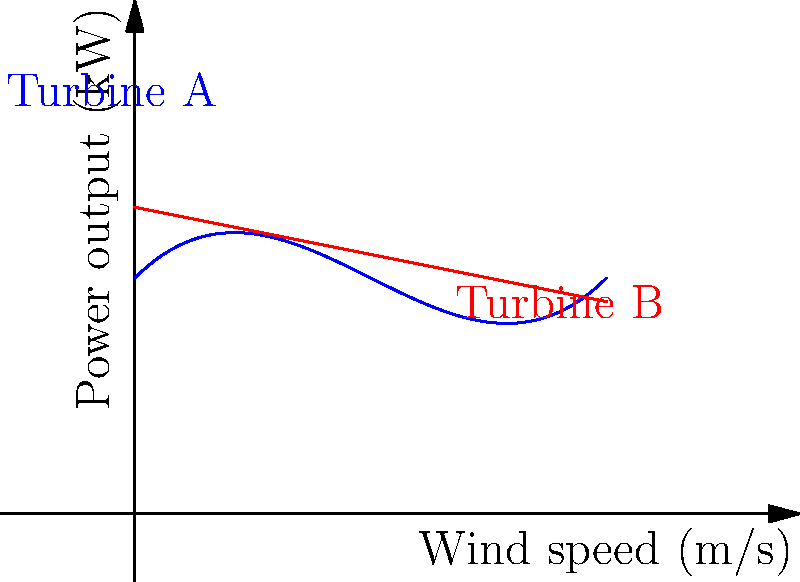A new wind turbine design (Turbine A) with sleek, streamlined blades is being compared to a standard model (Turbine B). The graph shows the power output of both turbines as a function of wind speed. At what wind speed does Turbine A become more efficient than Turbine B? To find the wind speed at which Turbine A becomes more efficient than Turbine B, we need to determine the intersection point of the two curves. This can be done through the following steps:

1. Identify the equations of the two curves:
   Turbine A: $y = 0.5x^3 - 1.5x^2 + x + 1$
   Turbine B: $y = -0.2x + 1.3$

2. Set the equations equal to each other to find the intersection point:
   $0.5x^3 - 1.5x^2 + x + 1 = -0.2x + 1.3$

3. Rearrange the equation:
   $0.5x^3 - 1.5x^2 + 1.2x - 0.3 = 0$

4. This is a cubic equation that can be solved using numerical methods or graphing software. The solution is approximately $x = 0.8$.

5. Verify that this is the only intersection point in the given range (0 to 2 m/s) by observing the graph.

Therefore, Turbine A becomes more efficient than Turbine B at a wind speed of approximately 0.8 m/s.
Answer: 0.8 m/s 